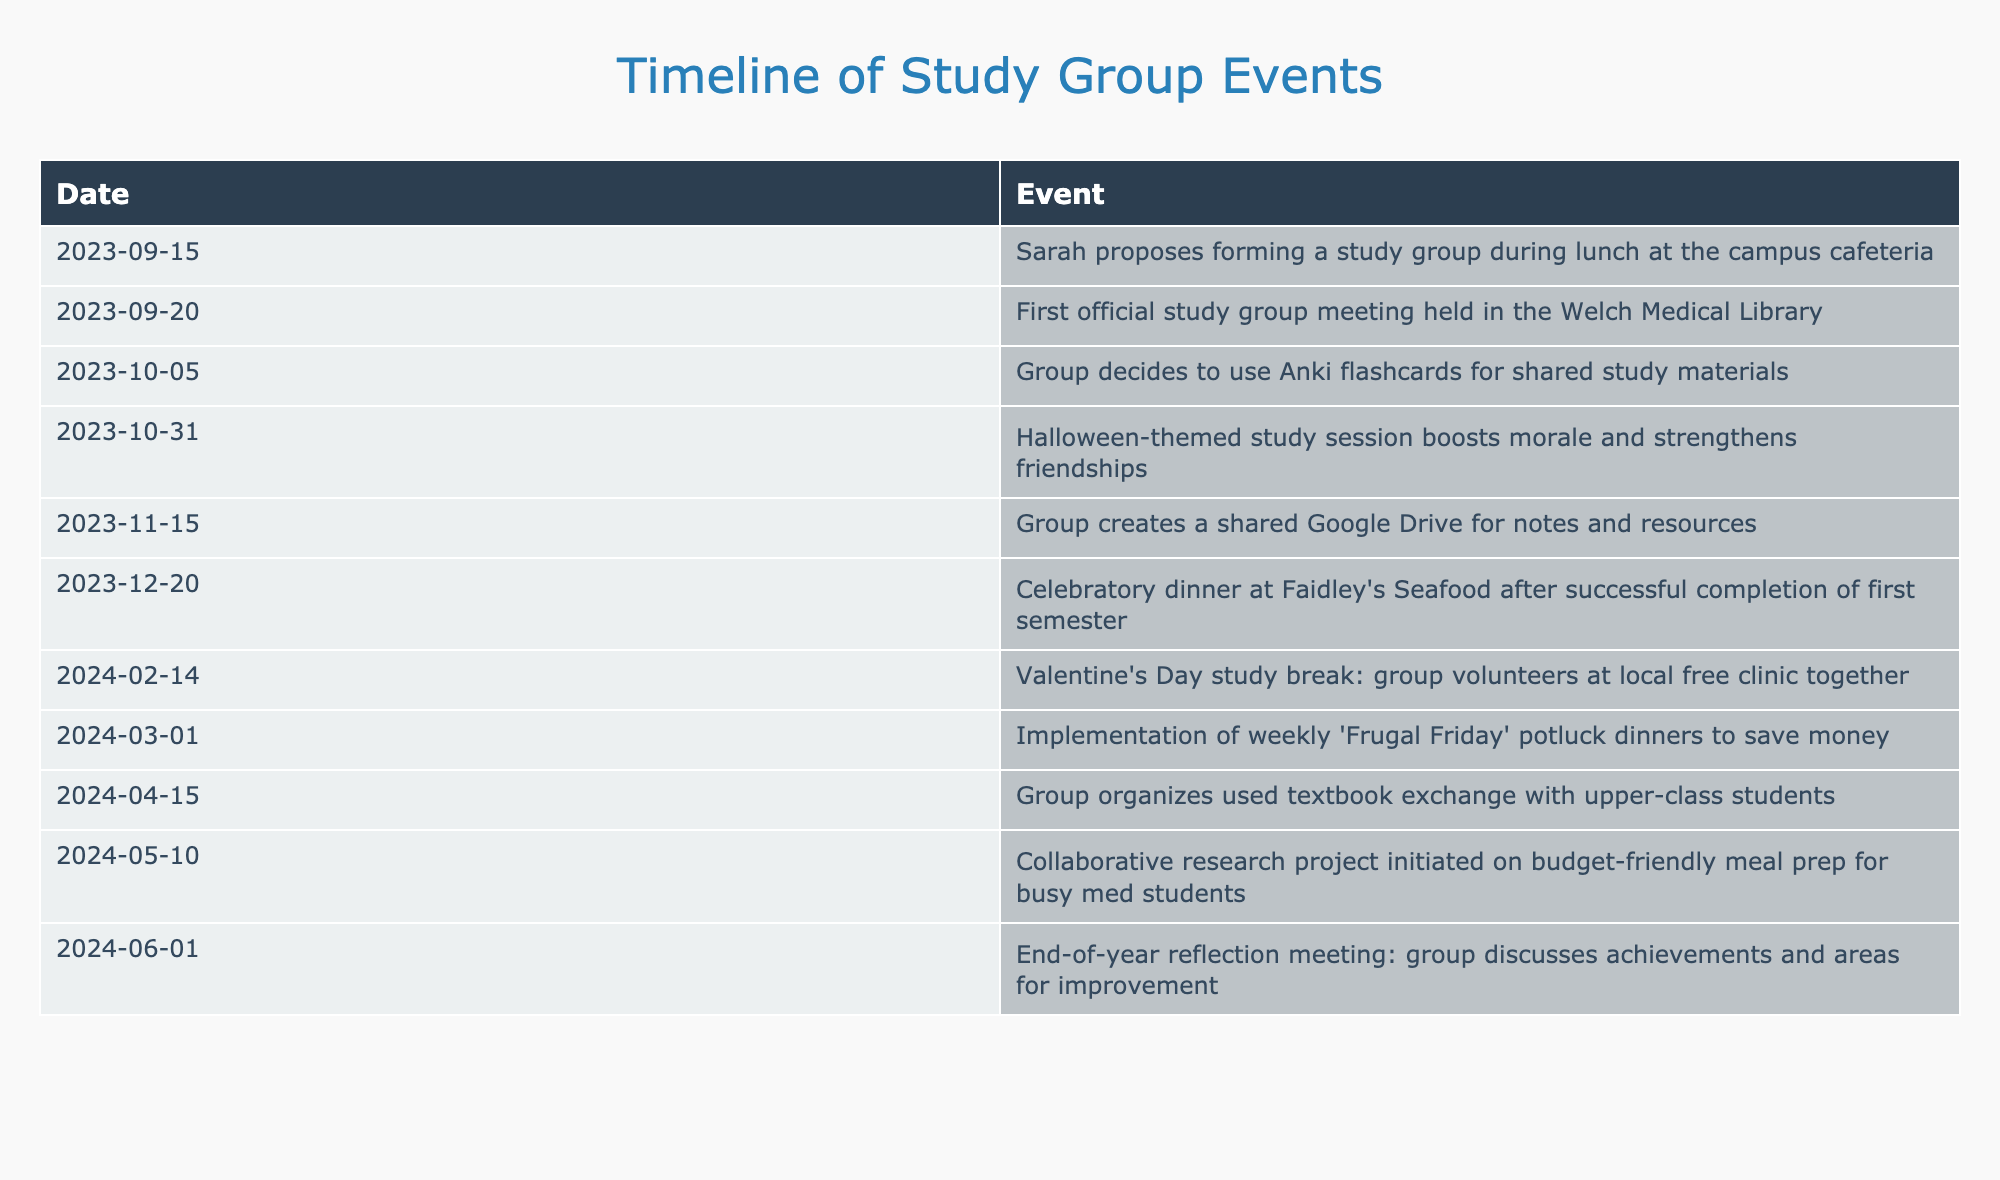What event was proposed by Sarah? The table shows that on September 15, 2023, Sarah proposed forming a study group during lunch at the campus cafeteria.
Answer: Sarah proposed forming a study group When was the first official study group meeting held? Referring to the table, the first official study group meeting was held on September 20, 2023, at the Welch Medical Library.
Answer: September 20, 2023 How many months passed between the creation of the shared Google Drive and the celebratory dinner? The shared Google Drive was created on November 15, 2023, and the celebratory dinner was on December 20, 2023. From November 15 to December 20 is 1 month and 5 days, so the answer is approximately 1 month.
Answer: 1 month Did the study group volunteer at a local free clinic? The timeline indicates that on February 14, 2024, the group volunteered at a local free clinic together.
Answer: Yes What was the date of the Halloween-themed study session? By checking the table, we see that the Halloween-themed study session occurred on October 31, 2023.
Answer: October 31, 2023 How many events took place between the first meeting and the end-of-year reflection meeting? The first meeting was on September 20, 2023, and the end-of-year reflection meeting was on June 1, 2024. There were six events listed between these two dates: from the event after the first meeting until the reflection meeting.
Answer: 6 events What type of sessions did the group initiate on March 1, 2024? The table indicates that on March 1, 2024, the group implemented weekly "Frugal Friday" potluck dinners.
Answer: Frugal Friday potluck dinners Which event marked the end of the first semester? According to the table, the celebratory dinner at Faidley's Seafood on December 20, 2023, marked the successful completion of the first semester.
Answer: Celebratory dinner 